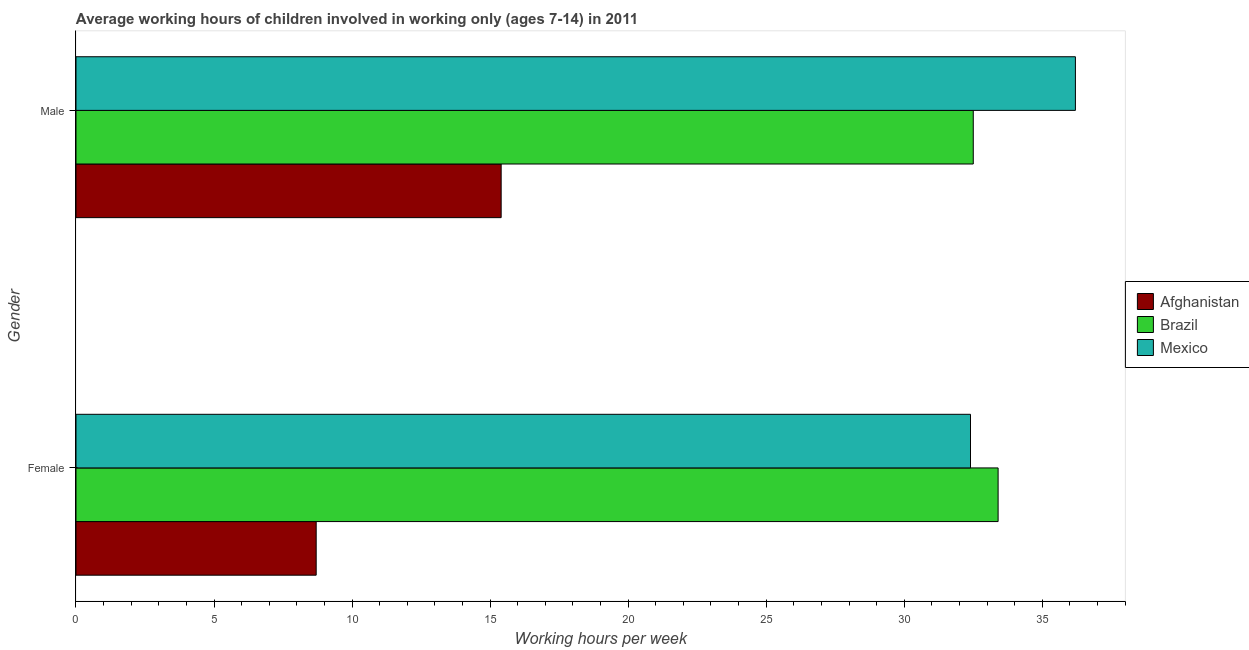How many groups of bars are there?
Your answer should be very brief. 2. How many bars are there on the 2nd tick from the top?
Your answer should be very brief. 3. How many bars are there on the 2nd tick from the bottom?
Provide a short and direct response. 3. Across all countries, what is the maximum average working hour of male children?
Ensure brevity in your answer.  36.2. In which country was the average working hour of female children minimum?
Keep it short and to the point. Afghanistan. What is the total average working hour of female children in the graph?
Offer a terse response. 74.5. What is the difference between the average working hour of male children in Afghanistan and that in Mexico?
Your answer should be compact. -20.8. What is the difference between the average working hour of male children in Mexico and the average working hour of female children in Afghanistan?
Keep it short and to the point. 27.5. What is the average average working hour of male children per country?
Provide a short and direct response. 28.03. What is the difference between the average working hour of male children and average working hour of female children in Afghanistan?
Offer a very short reply. 6.7. What is the ratio of the average working hour of male children in Mexico to that in Brazil?
Make the answer very short. 1.11. What does the 3rd bar from the top in Male represents?
Your answer should be very brief. Afghanistan. What does the 3rd bar from the bottom in Male represents?
Your response must be concise. Mexico. How many countries are there in the graph?
Ensure brevity in your answer.  3. Are the values on the major ticks of X-axis written in scientific E-notation?
Your response must be concise. No. Where does the legend appear in the graph?
Offer a very short reply. Center right. How many legend labels are there?
Keep it short and to the point. 3. How are the legend labels stacked?
Provide a short and direct response. Vertical. What is the title of the graph?
Your answer should be very brief. Average working hours of children involved in working only (ages 7-14) in 2011. What is the label or title of the X-axis?
Your response must be concise. Working hours per week. What is the Working hours per week in Brazil in Female?
Your response must be concise. 33.4. What is the Working hours per week in Mexico in Female?
Provide a short and direct response. 32.4. What is the Working hours per week of Afghanistan in Male?
Offer a very short reply. 15.4. What is the Working hours per week of Brazil in Male?
Provide a short and direct response. 32.5. What is the Working hours per week of Mexico in Male?
Keep it short and to the point. 36.2. Across all Gender, what is the maximum Working hours per week in Brazil?
Offer a very short reply. 33.4. Across all Gender, what is the maximum Working hours per week in Mexico?
Provide a succinct answer. 36.2. Across all Gender, what is the minimum Working hours per week of Brazil?
Provide a short and direct response. 32.5. Across all Gender, what is the minimum Working hours per week of Mexico?
Provide a short and direct response. 32.4. What is the total Working hours per week in Afghanistan in the graph?
Offer a terse response. 24.1. What is the total Working hours per week of Brazil in the graph?
Your answer should be compact. 65.9. What is the total Working hours per week in Mexico in the graph?
Your answer should be very brief. 68.6. What is the difference between the Working hours per week of Brazil in Female and that in Male?
Give a very brief answer. 0.9. What is the difference between the Working hours per week in Mexico in Female and that in Male?
Offer a very short reply. -3.8. What is the difference between the Working hours per week in Afghanistan in Female and the Working hours per week in Brazil in Male?
Your response must be concise. -23.8. What is the difference between the Working hours per week in Afghanistan in Female and the Working hours per week in Mexico in Male?
Offer a terse response. -27.5. What is the average Working hours per week in Afghanistan per Gender?
Your answer should be very brief. 12.05. What is the average Working hours per week in Brazil per Gender?
Keep it short and to the point. 32.95. What is the average Working hours per week in Mexico per Gender?
Offer a very short reply. 34.3. What is the difference between the Working hours per week in Afghanistan and Working hours per week in Brazil in Female?
Offer a very short reply. -24.7. What is the difference between the Working hours per week of Afghanistan and Working hours per week of Mexico in Female?
Make the answer very short. -23.7. What is the difference between the Working hours per week of Brazil and Working hours per week of Mexico in Female?
Offer a terse response. 1. What is the difference between the Working hours per week of Afghanistan and Working hours per week of Brazil in Male?
Your response must be concise. -17.1. What is the difference between the Working hours per week of Afghanistan and Working hours per week of Mexico in Male?
Ensure brevity in your answer.  -20.8. What is the difference between the Working hours per week in Brazil and Working hours per week in Mexico in Male?
Your response must be concise. -3.7. What is the ratio of the Working hours per week in Afghanistan in Female to that in Male?
Your response must be concise. 0.56. What is the ratio of the Working hours per week in Brazil in Female to that in Male?
Your response must be concise. 1.03. What is the ratio of the Working hours per week of Mexico in Female to that in Male?
Provide a short and direct response. 0.9. What is the difference between the highest and the second highest Working hours per week of Brazil?
Provide a succinct answer. 0.9. What is the difference between the highest and the lowest Working hours per week in Afghanistan?
Your answer should be compact. 6.7. What is the difference between the highest and the lowest Working hours per week of Brazil?
Your response must be concise. 0.9. What is the difference between the highest and the lowest Working hours per week of Mexico?
Your response must be concise. 3.8. 